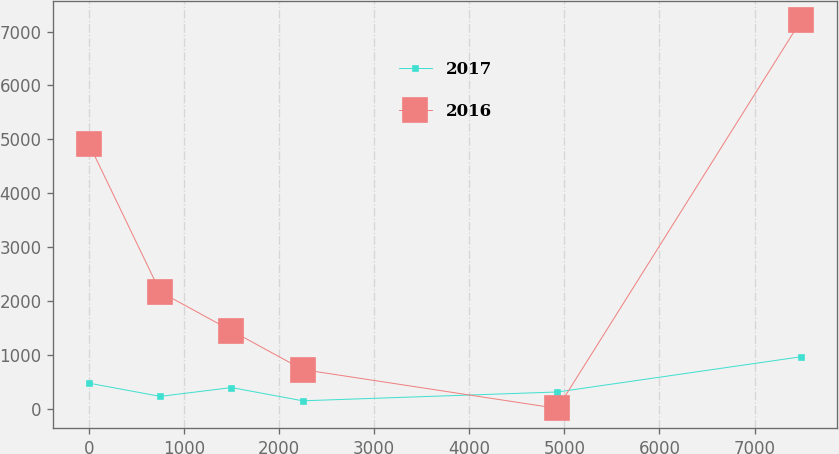Convert chart to OTSL. <chart><loc_0><loc_0><loc_500><loc_500><line_chart><ecel><fcel>2017<fcel>2016<nl><fcel>2.37<fcel>470.77<fcel>4910.33<nl><fcel>751.34<fcel>225.16<fcel>2165.53<nl><fcel>1500.31<fcel>388.9<fcel>1444.28<nl><fcel>2249.28<fcel>143.28<fcel>723.03<nl><fcel>4926.91<fcel>307.03<fcel>1.78<nl><fcel>7492.03<fcel>962.03<fcel>7214.26<nl></chart> 